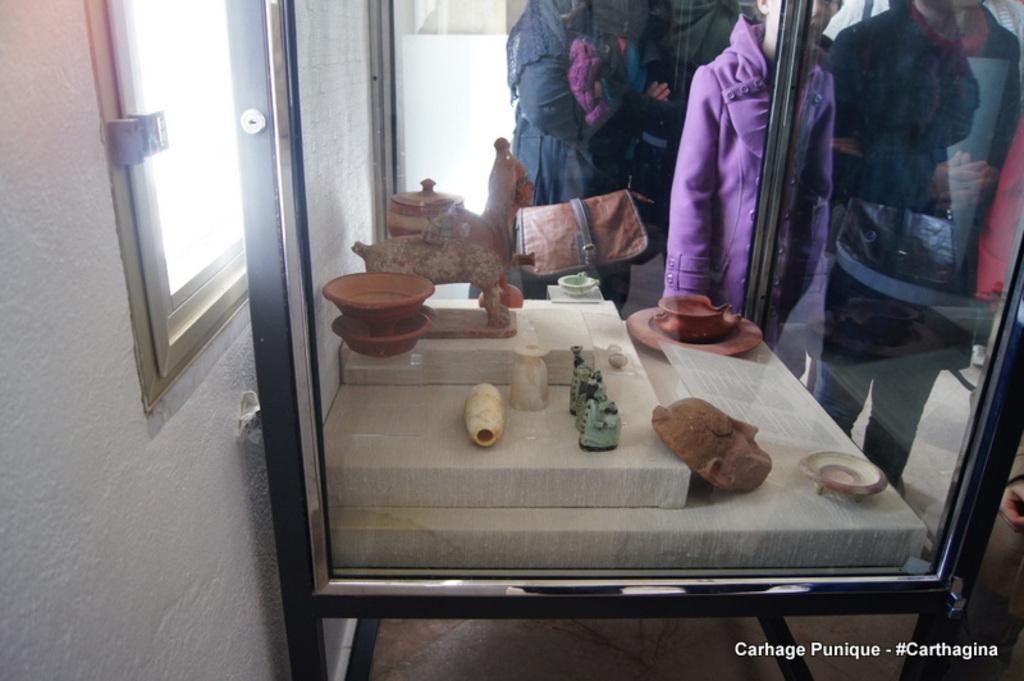How would you summarize this image in a sentence or two? In this image there are a few objects arranged and covered with glass from four sides, in front of them there a few people standing on the floor, at the bottom of the image there is some text. On the left side of the image there is a wall with a window. 